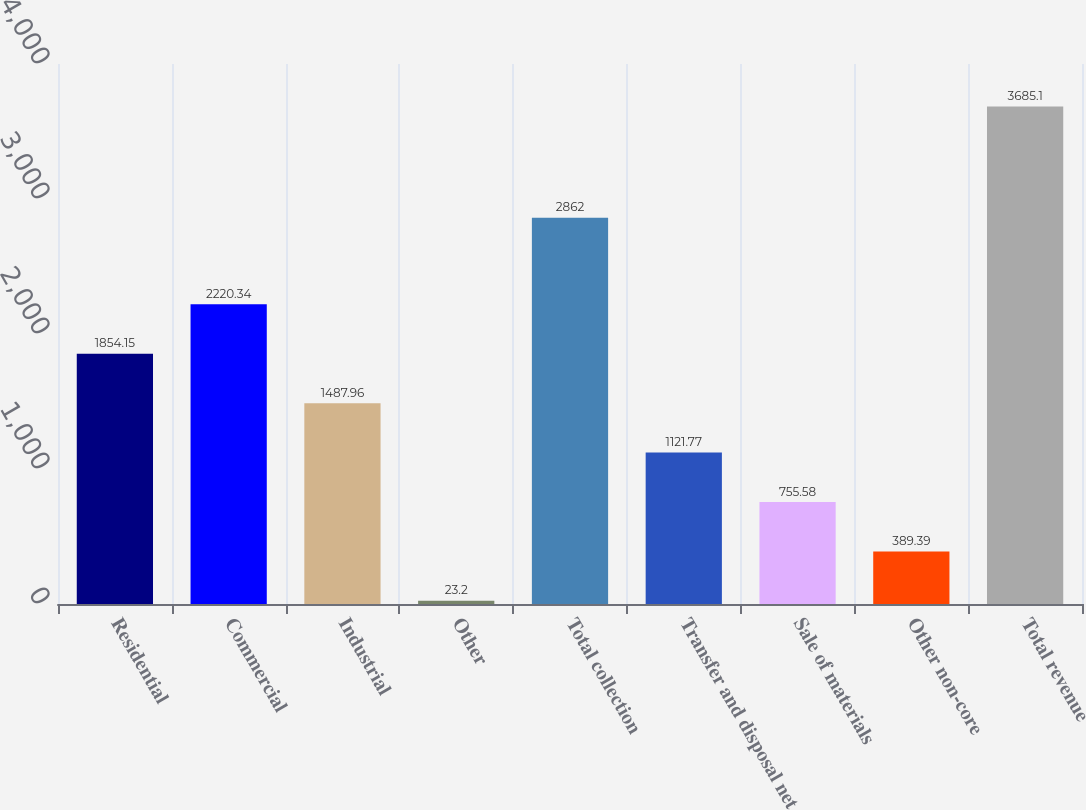Convert chart. <chart><loc_0><loc_0><loc_500><loc_500><bar_chart><fcel>Residential<fcel>Commercial<fcel>Industrial<fcel>Other<fcel>Total collection<fcel>Transfer and disposal net<fcel>Sale of materials<fcel>Other non-core<fcel>Total revenue<nl><fcel>1854.15<fcel>2220.34<fcel>1487.96<fcel>23.2<fcel>2862<fcel>1121.77<fcel>755.58<fcel>389.39<fcel>3685.1<nl></chart> 